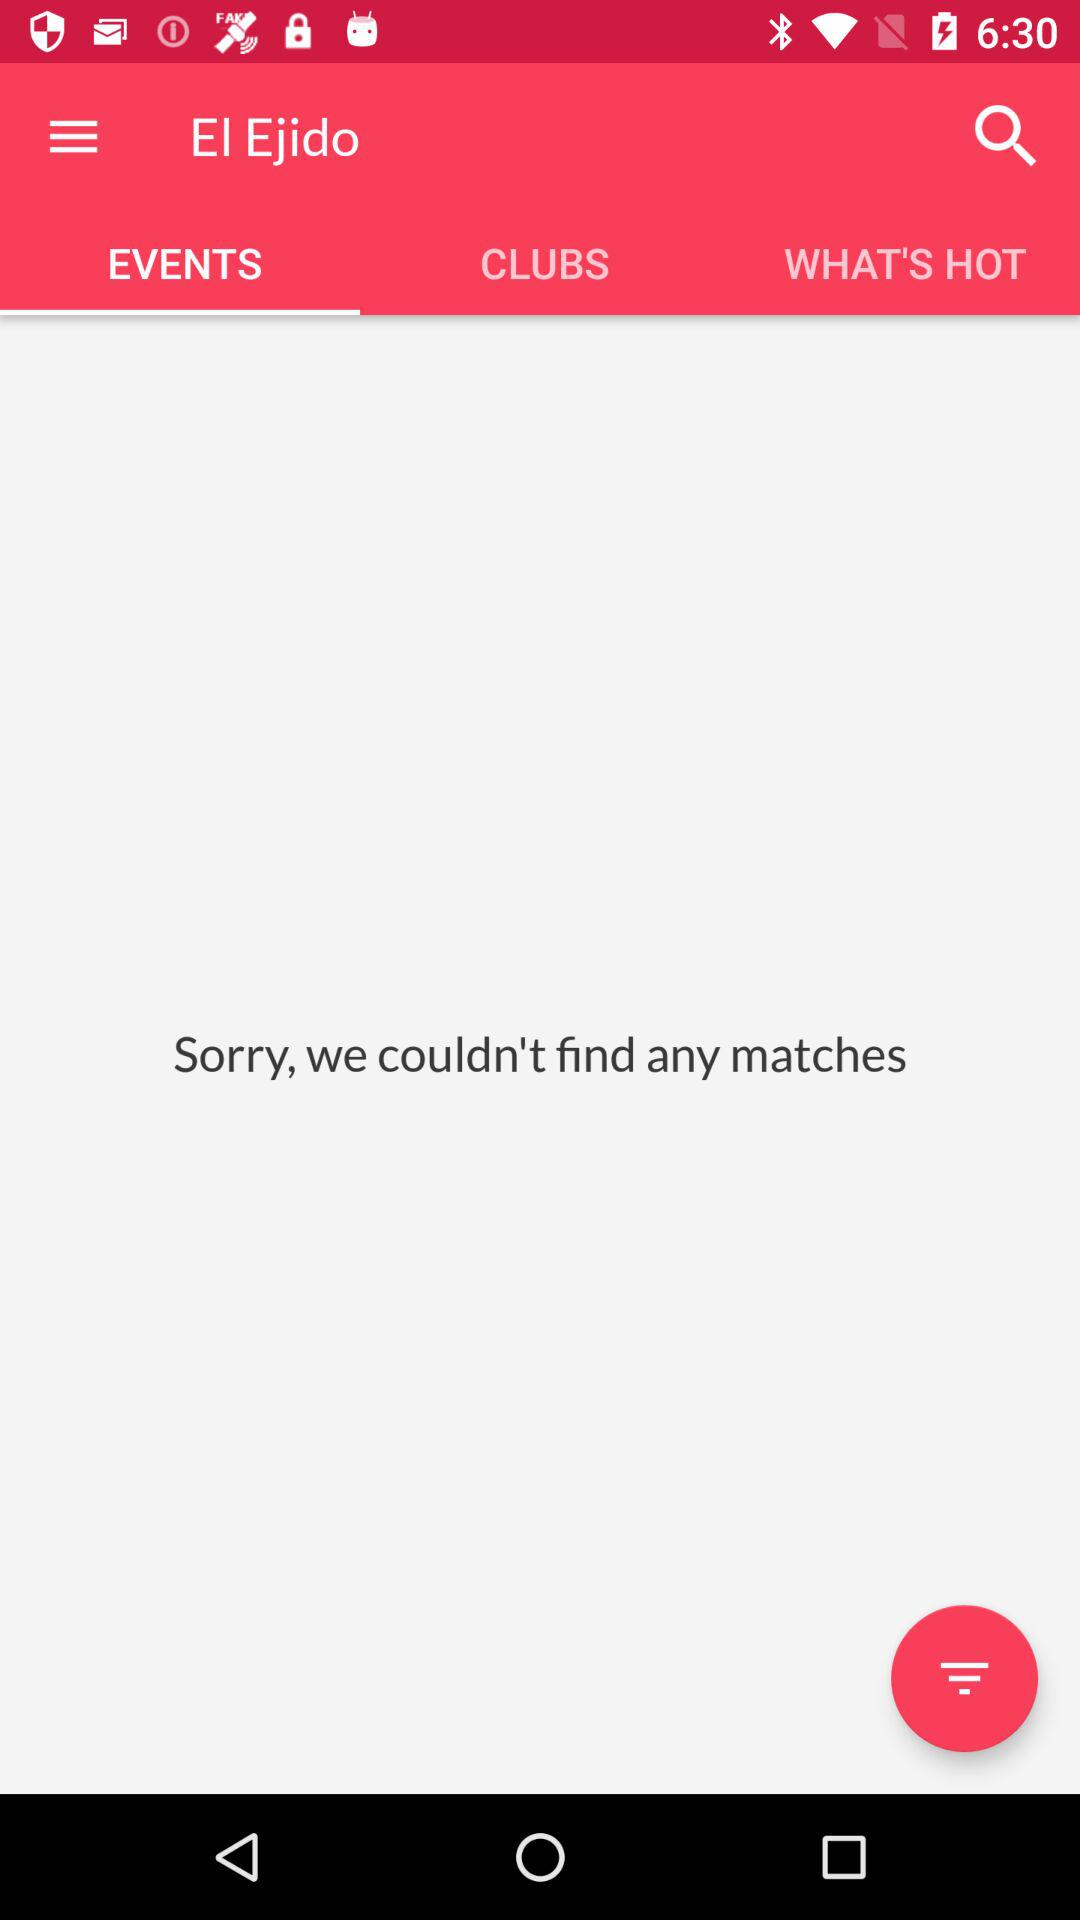What is the selected tab? The selected tab is "EVENTS". 